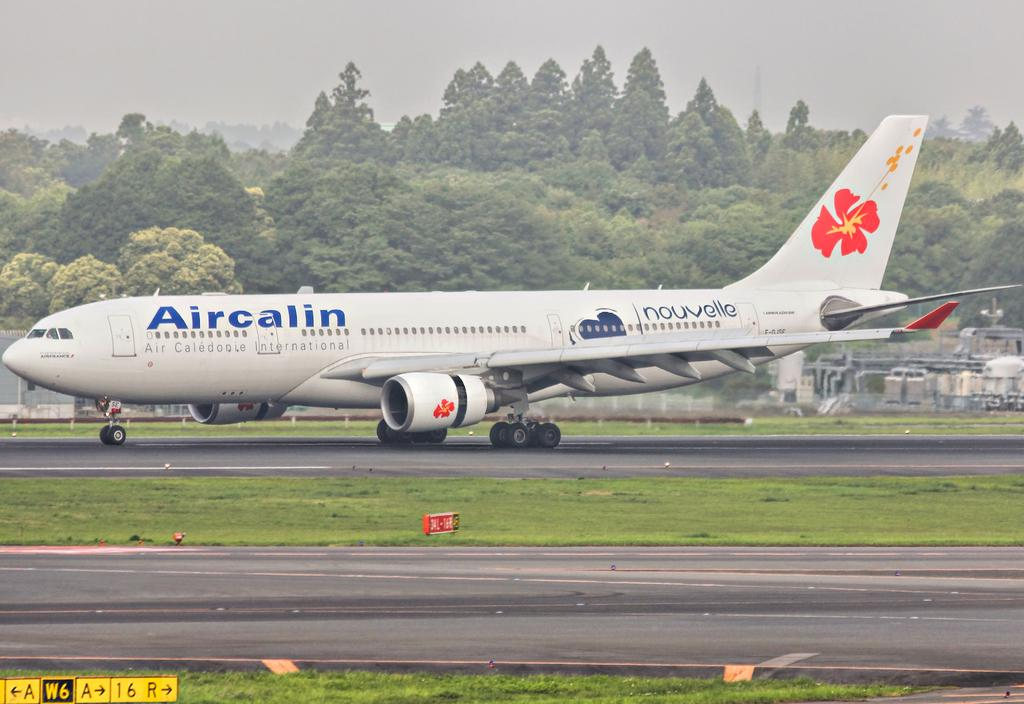<image>
Give a short and clear explanation of the subsequent image. an airplane on a runway, branded with a aircalin decal 